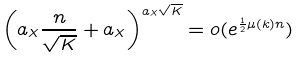<formula> <loc_0><loc_0><loc_500><loc_500>\left ( a _ { X } \frac { n } { \sqrt { K } } + a _ { X } \right ) ^ { a _ { X } \sqrt { K } } = o ( e ^ { \frac { 1 } { 2 } \mu ( k ) n } )</formula> 